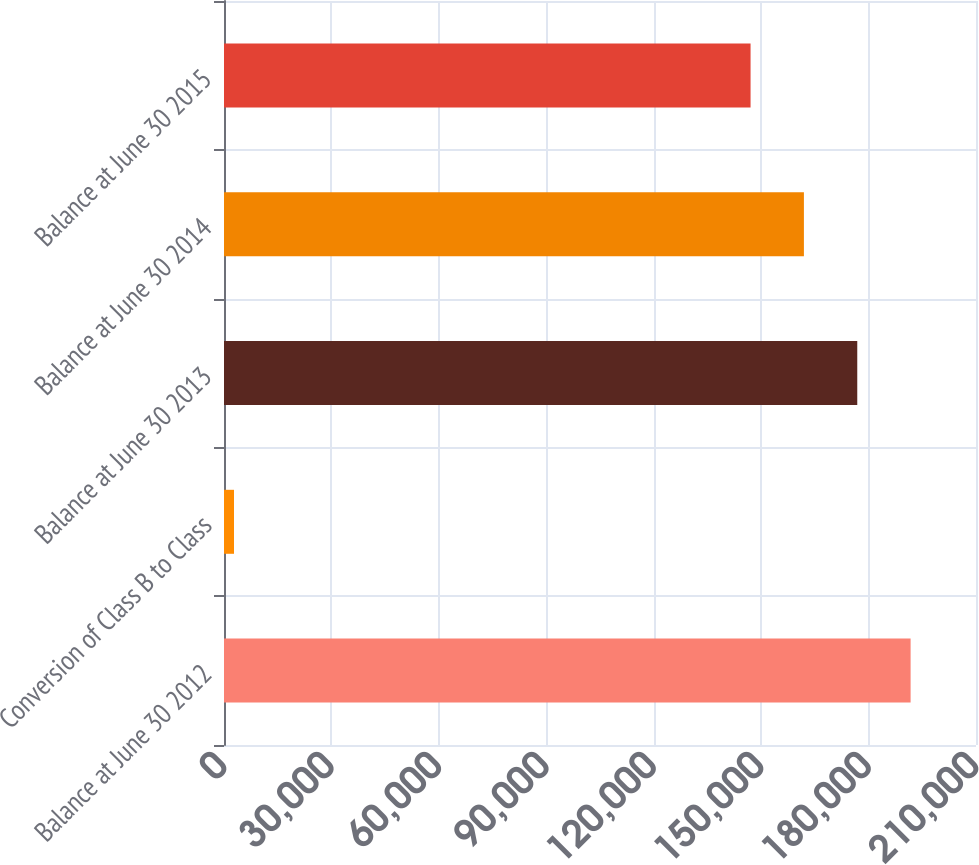<chart> <loc_0><loc_0><loc_500><loc_500><bar_chart><fcel>Balance at June 30 2012<fcel>Conversion of Class B to Class<fcel>Balance at June 30 2013<fcel>Balance at June 30 2014<fcel>Balance at June 30 2015<nl><fcel>191740<fcel>2800<fcel>176842<fcel>161944<fcel>147046<nl></chart> 